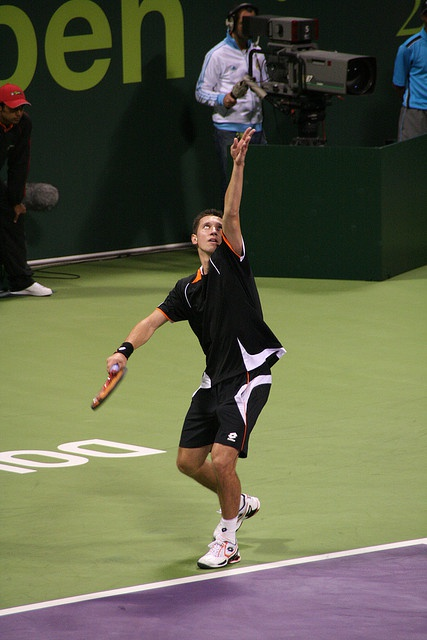Describe the objects in this image and their specific colors. I can see people in black, olive, brown, and lavender tones, people in black, darkgray, and gray tones, people in black, maroon, brown, and darkgray tones, people in black, blue, and navy tones, and tennis racket in black, olive, brown, gray, and tan tones in this image. 